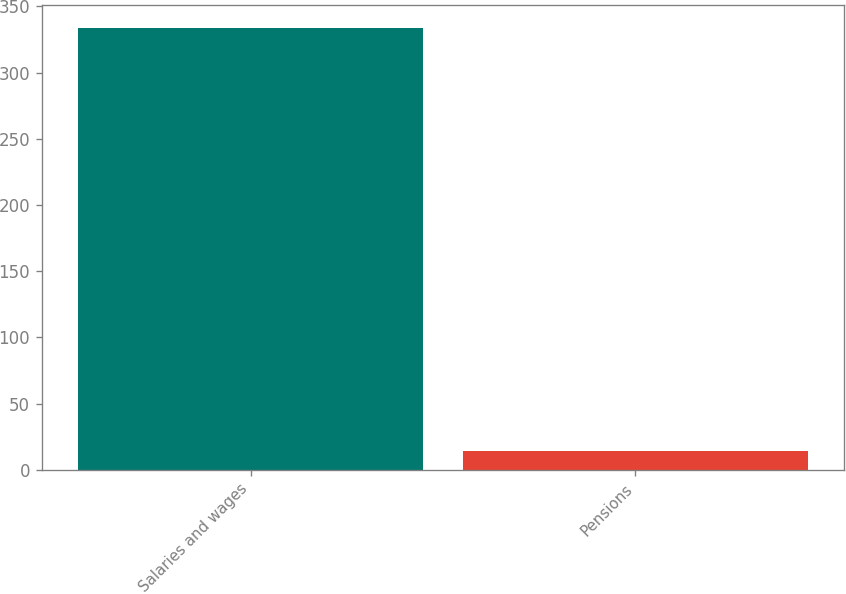Convert chart. <chart><loc_0><loc_0><loc_500><loc_500><bar_chart><fcel>Salaries and wages<fcel>Pensions<nl><fcel>334<fcel>14<nl></chart> 